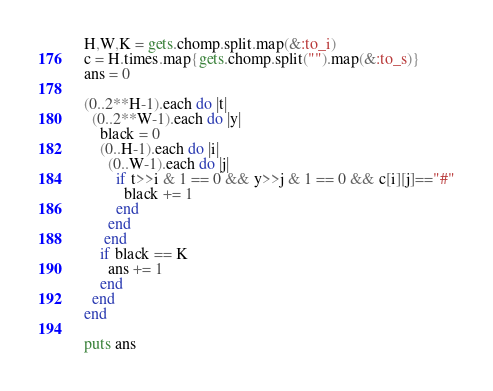<code> <loc_0><loc_0><loc_500><loc_500><_Ruby_>H,W,K = gets.chomp.split.map(&:to_i)
c = H.times.map{gets.chomp.split("").map(&:to_s)}
ans = 0

(0..2**H-1).each do |t|
  (0..2**W-1).each do |y|
    black = 0
    (0..H-1).each do |i|
      (0..W-1).each do |j|
        if t>>i & 1 == 0 && y>>j & 1 == 0 && c[i][j]=="#"
          black += 1
        end
      end
     end
    if black == K
      ans += 1
    end
  end
end

puts ans

</code> 